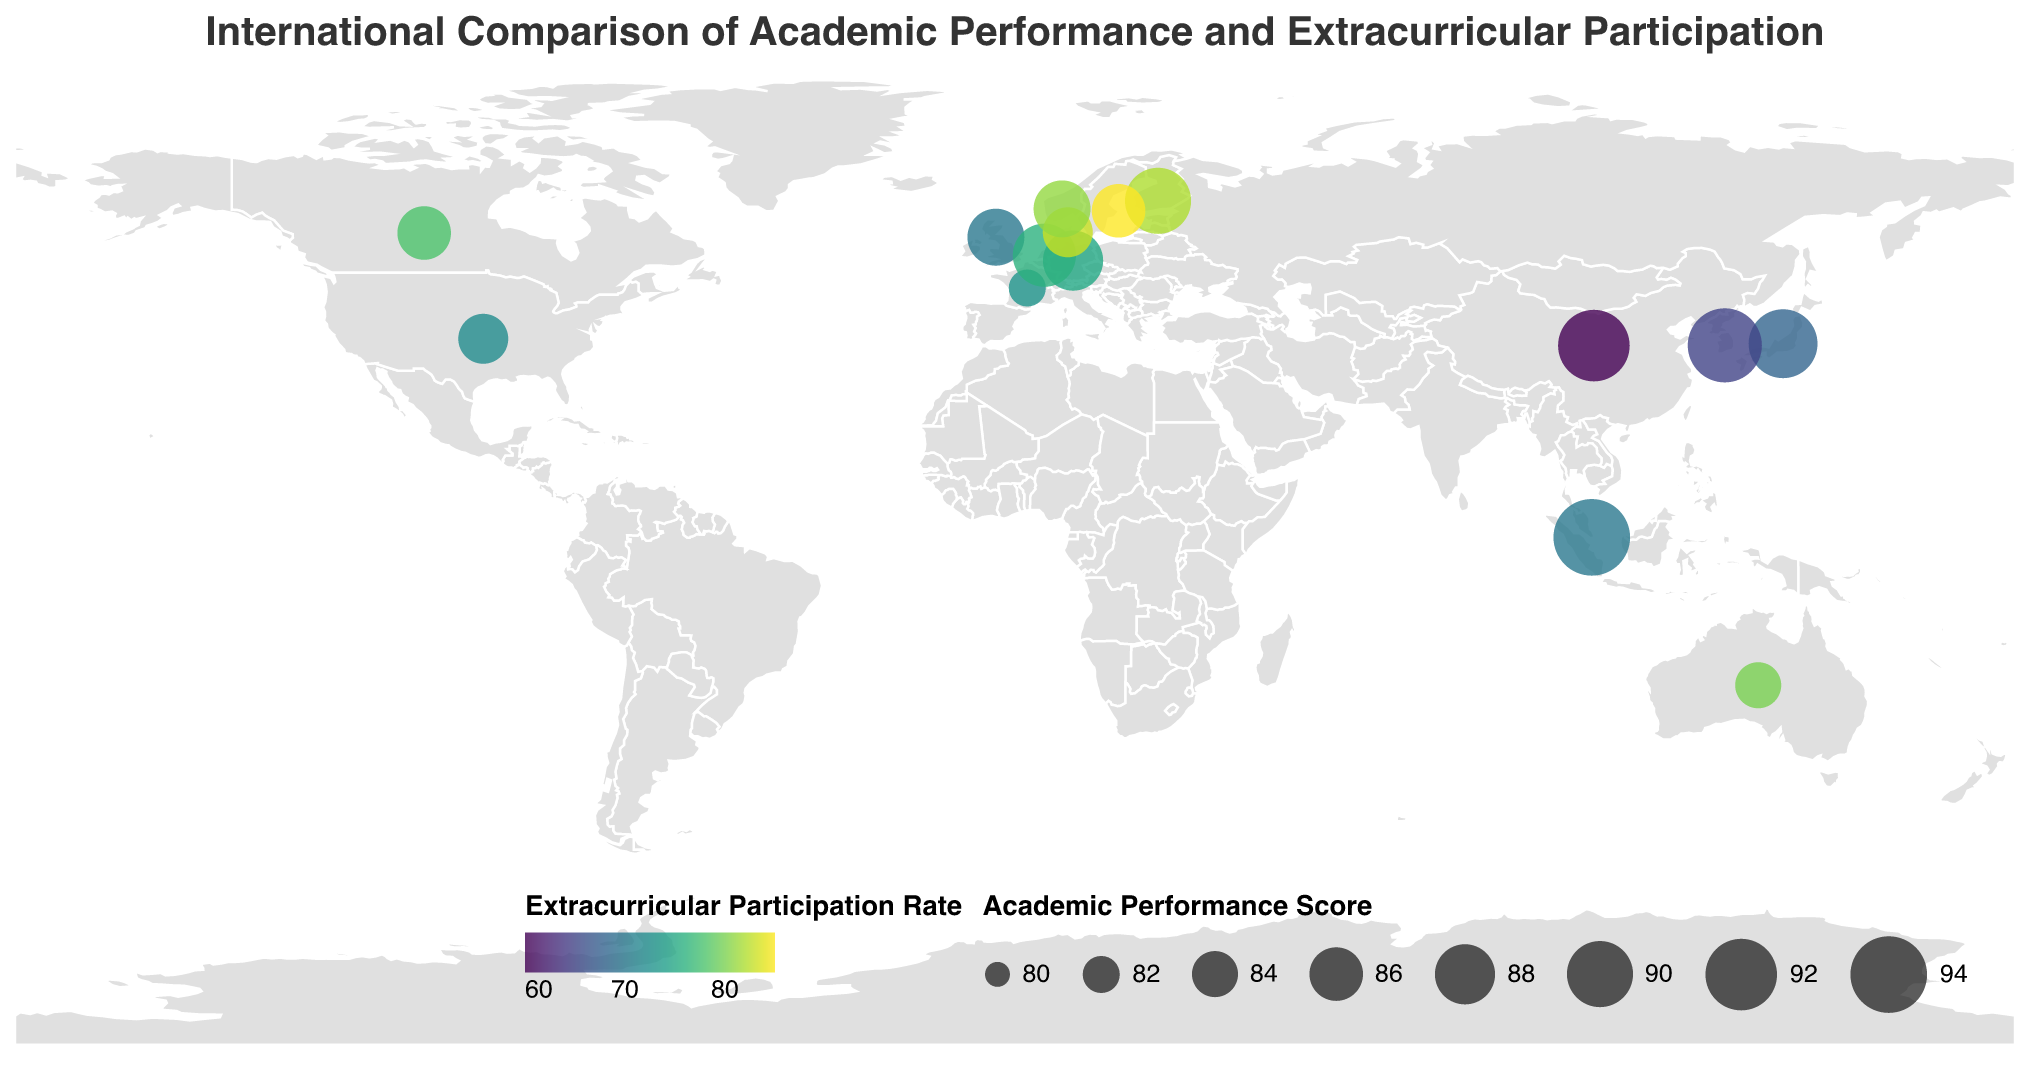What's the country with the highest academic performance score? Look at the size of the circles in the figure. Larger circles indicate higher academic performance scores. Singapore has the largest circle, which means it has the highest academic performance score.
Answer: Singapore Which country has the highest extracurricular participation rate? Look at the color of the circles. Darker shades of the color scheme indicate a higher extracurricular participation rate. Sweden has the darkest color, indicating it has the highest participation rate.
Answer: Sweden Which country has the lowest academic performance score? Look at the size of the circles. The smallest circle will indicate the lowest academic performance score. France and Australia have the smallest circles, and since their scores are both 84, they share the lowest score.
Answer: France and Australia What is the average academic performance score of the countries listed? Sum the academic performance scores of all the countries and divide by the number of countries. The sum is 1301 (85 + 91 + 88 + 87 + 93 + 86 + 84 + 82 + 89 + 90 + 94 + 92 + 86 + 85 + 87), and there are 15 countries. 1301 / 15 ≈ 86.73
Answer: 86.73 What is the difference in extracurricular participation rate between China and Sweden? Subtract China's extracurricular participation rate (60) from Sweden's extracurricular participation rate (85). 85 - 60 = 25
Answer: 25 Which country has the largest discrepancy between academic performance and extracurricular participation rates? Compare the difference between academic performance score and extracurricular participation rate for each country. China has a score of 92 and participation rate of 60, giving a discrepancy of 32, which is the largest discrepancy.
Answer: China Compare the academic performance scores of the United States and Germany. Which one is higher? Look at the size of the circles for the United States and Germany. The larger circle indicates a higher academic performance score. Germany's circle is larger (88) compared to the United States (85).
Answer: Germany What is the median academic performance score from the listed countries? Arrange the academic performance scores in ascending order and find the middle value. Ordered scores: 82, 84, 84, 85, 85, 86, 86, 87, 87, 88, 89, 90, 91, 92, 93, 94. Since there are 15 countries, the median is the 8th score, which is 87.
Answer: 87 Which countries have both high academic performance (score ≥ 90) and high extracurricular participation (rate ≥ 70)? Identify the countries that satisfy both conditions by examining the size and color of the circles. Finland and Singapore meet both criteria with Finland having scores of 90 and 82, and Singapore scores of 94 and 70.
Answer: Finland and Singapore 